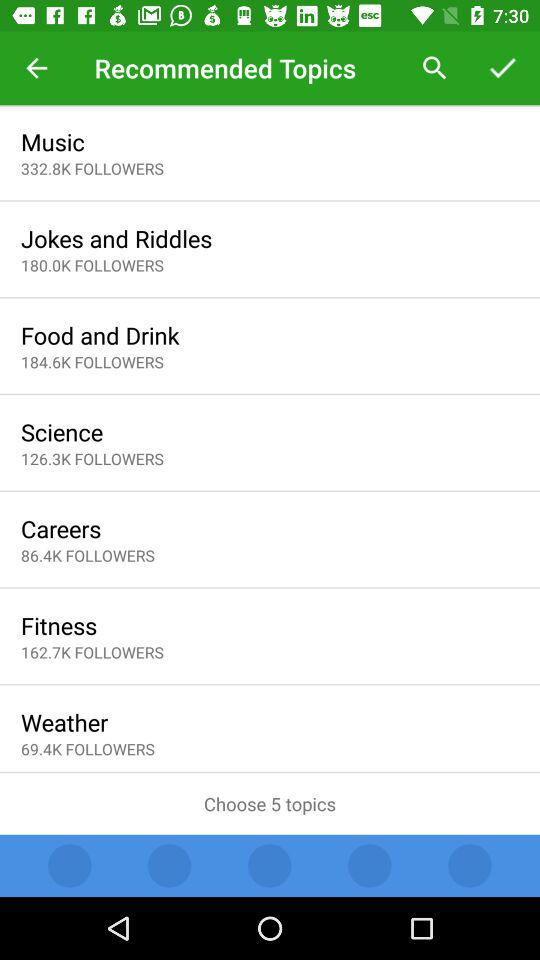How many topics are to be chosen? There are 5 topics to be chosen. 